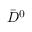<formula> <loc_0><loc_0><loc_500><loc_500>\bar { D } ^ { 0 }</formula> 